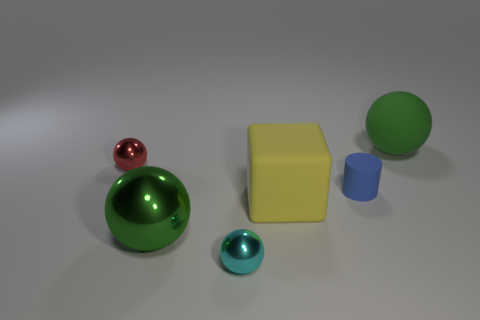The big thing that is on the left side of the big yellow thing has what shape?
Your answer should be compact. Sphere. The ball that is the same material as the yellow block is what size?
Provide a succinct answer. Large. There is a metallic object that is both behind the cyan shiny sphere and in front of the blue thing; what is its shape?
Offer a very short reply. Sphere. Do the tiny shiny ball behind the large green shiny object and the small matte thing have the same color?
Provide a short and direct response. No. Do the large green object that is in front of the big green rubber ball and the tiny object that is on the left side of the small cyan metallic object have the same shape?
Provide a succinct answer. Yes. What size is the green ball that is in front of the green matte sphere?
Your response must be concise. Large. How big is the green ball that is in front of the large green sphere to the right of the tiny cylinder?
Keep it short and to the point. Large. Are there more purple rubber things than big green metallic things?
Your answer should be very brief. No. Are there more small matte cylinders that are in front of the yellow object than green metal things that are behind the small red metal thing?
Offer a terse response. No. What size is the rubber thing that is in front of the red metal thing and behind the big yellow matte object?
Provide a short and direct response. Small. 